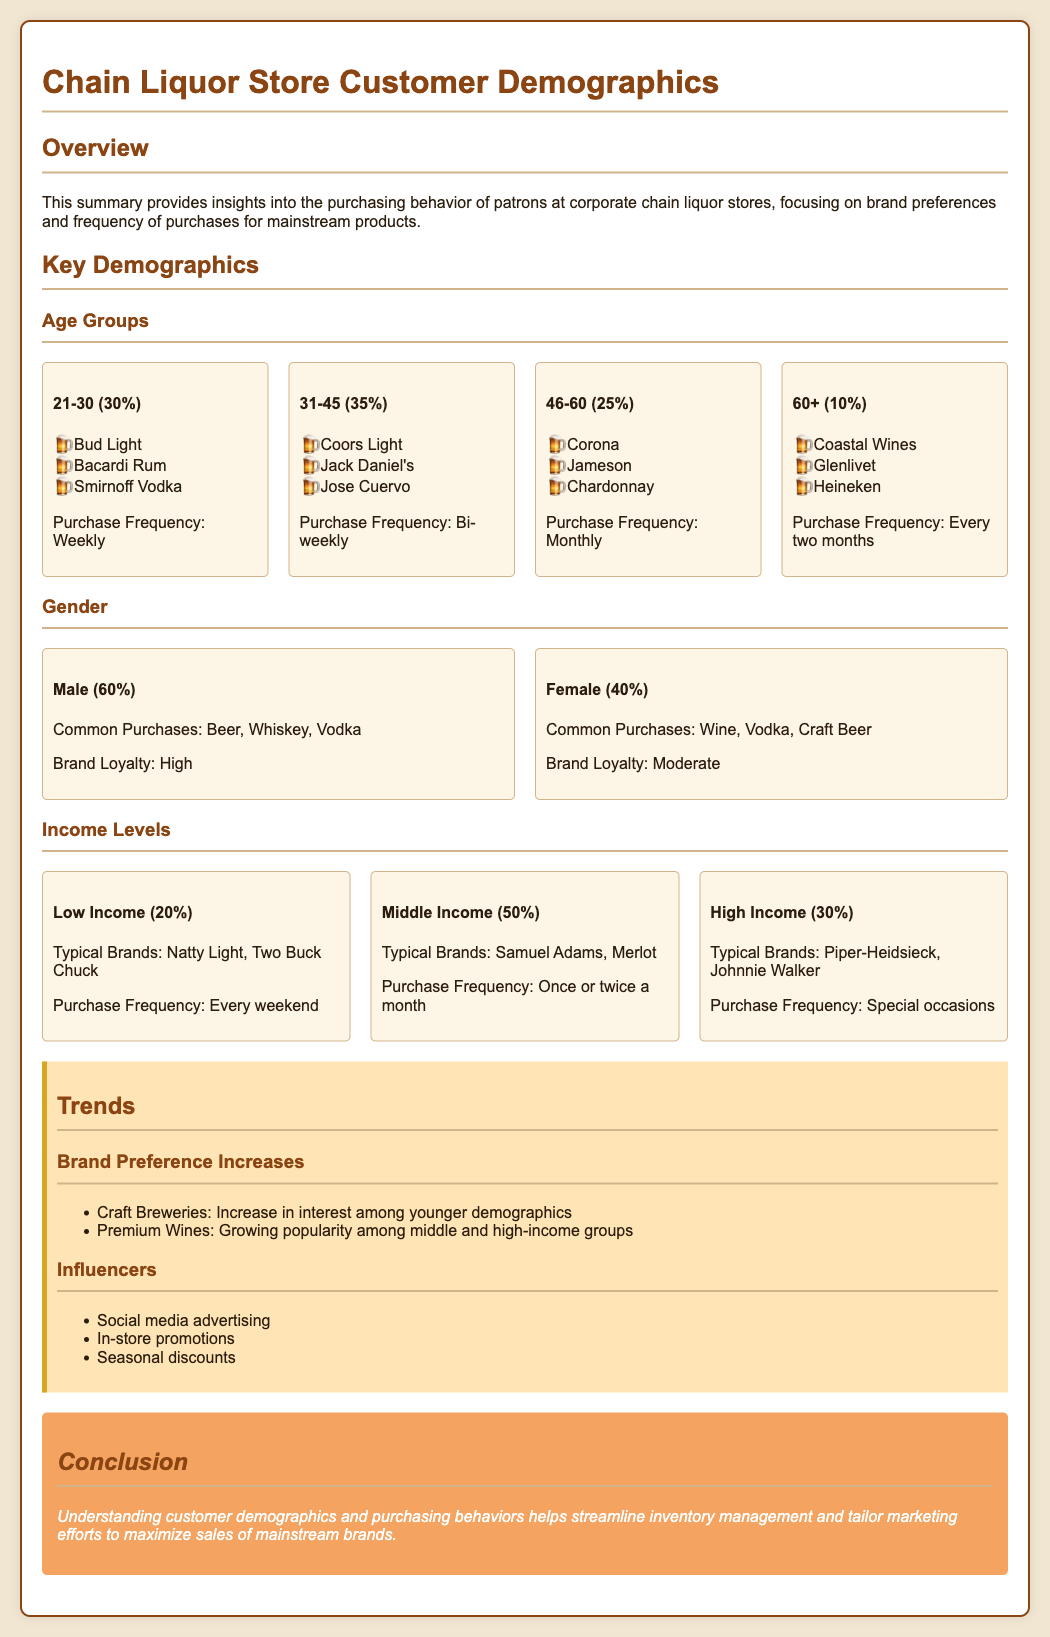What is the age group with the highest purchasing frequency? The 21-30 age group has a purchase frequency of "Weekly," which is the highest among all groups.
Answer: Weekly What percentage of customers are aged 31-45? The document states that 35% of customers fall within the 31-45 age group.
Answer: 35% What brands do males prefer for common purchases? Males commonly purchase Beer, Whiskey, and Vodka, as stated in the document.
Answer: Beer, Whiskey, Vodka What is the typical brand for low-income customers? The document lists "Natty Light" and "Two Buck Chuck" as typical brands for low-income customers.
Answer: Natty Light, Two Buck Chuck How often do high-income customers make purchases? High-income customers are noted to make purchases primarily on "Special occasions."
Answer: Special occasions What trend is increasing among younger demographics? The document notes an increase in interest in "Craft Breweries" among younger demographics.
Answer: Craft Breweries What is the gender distribution for liquor store patrons? The gender distribution indicates 60% Male and 40% Female among patrons.
Answer: 60% Male, 40% Female What is the purchase frequency for the 46-60 age group? The 46-60 age group has a purchase frequency listed as "Monthly."
Answer: Monthly What kind of brands do middle-income customers typically buy? Middle-income customers typically buy brands like "Samuel Adams" and "Merlot."
Answer: Samuel Adams, Merlot 